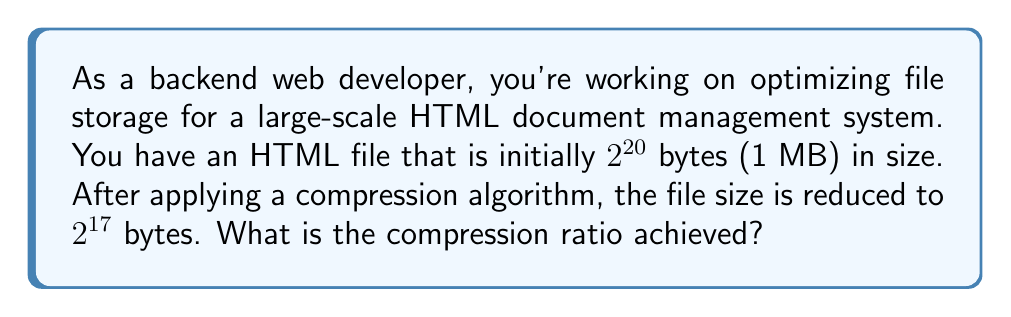Show me your answer to this math problem. To solve this problem, we need to understand the concept of compression ratio and how to calculate it using powers of 2.

1. The compression ratio is defined as:
   $$ \text{Compression Ratio} = \frac{\text{Original Size}}{\text{Compressed Size}} $$

2. Given:
   - Original file size: $2^{20}$ bytes
   - Compressed file size: $2^{17}$ bytes

3. Substituting these values into the compression ratio formula:
   $$ \text{Compression Ratio} = \frac{2^{20}}{2^{17}} $$

4. To simplify this fraction, we can use the properties of exponents:
   $$ \frac{2^{20}}{2^{17}} = 2^{20-17} = 2^3 $$

5. Calculate the final value:
   $$ 2^3 = 8 $$

Therefore, the compression ratio achieved is 8:1, which means the original file is 8 times larger than the compressed file.
Answer: The compression ratio achieved is 8:1 or simply 8. 